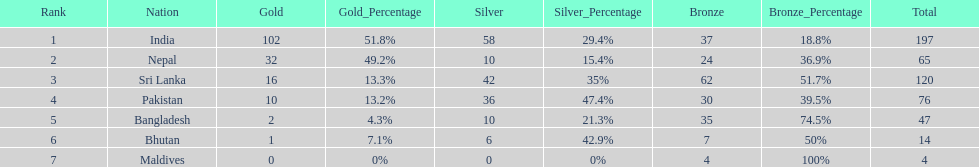What was the only nation to win less than 10 medals total? Maldives. 